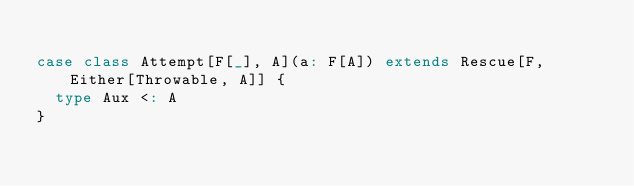Convert code to text. <code><loc_0><loc_0><loc_500><loc_500><_Scala_>
case class Attempt[F[_], A](a: F[A]) extends Rescue[F, Either[Throwable, A]] {
  type Aux <: A
}
</code> 